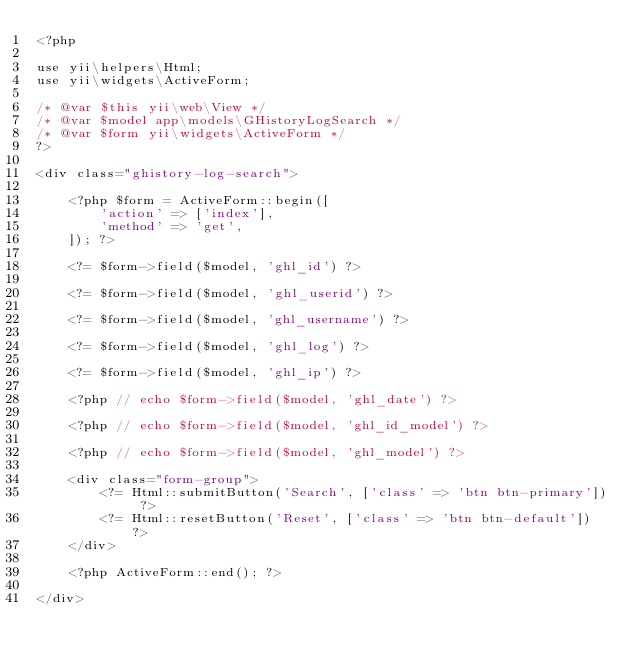Convert code to text. <code><loc_0><loc_0><loc_500><loc_500><_PHP_><?php

use yii\helpers\Html;
use yii\widgets\ActiveForm;

/* @var $this yii\web\View */
/* @var $model app\models\GHistoryLogSearch */
/* @var $form yii\widgets\ActiveForm */
?>

<div class="ghistory-log-search">

    <?php $form = ActiveForm::begin([
        'action' => ['index'],
        'method' => 'get',
    ]); ?>

    <?= $form->field($model, 'ghl_id') ?>

    <?= $form->field($model, 'ghl_userid') ?>

    <?= $form->field($model, 'ghl_username') ?>

    <?= $form->field($model, 'ghl_log') ?>

    <?= $form->field($model, 'ghl_ip') ?>

    <?php // echo $form->field($model, 'ghl_date') ?>

    <?php // echo $form->field($model, 'ghl_id_model') ?>

    <?php // echo $form->field($model, 'ghl_model') ?>

    <div class="form-group">
        <?= Html::submitButton('Search', ['class' => 'btn btn-primary']) ?>
        <?= Html::resetButton('Reset', ['class' => 'btn btn-default']) ?>
    </div>

    <?php ActiveForm::end(); ?>

</div>
</code> 